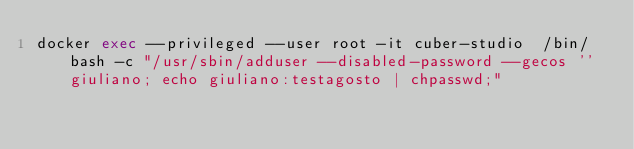<code> <loc_0><loc_0><loc_500><loc_500><_Bash_>docker exec --privileged --user root -it cuber-studio  /bin/bash -c "/usr/sbin/adduser --disabled-password --gecos '' giuliano; echo giuliano:testagosto | chpasswd;"

</code> 